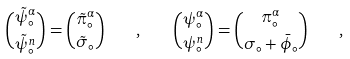Convert formula to latex. <formula><loc_0><loc_0><loc_500><loc_500>\binom { { \tilde { \psi } } _ { \circ } ^ { \alpha } } { { \tilde { \psi } } _ { \circ } ^ { n } } = \binom { { \tilde { \pi } } _ { \circ } ^ { \alpha } } { { \tilde { \sigma } } _ { \circ } } \quad , \quad \binom { \psi _ { \circ } ^ { \alpha } } { \psi _ { \circ } ^ { n } } = \binom { \pi _ { \circ } ^ { \alpha } } { \sigma _ { \circ } + { \bar { \phi } } _ { \circ } } \quad ,</formula> 